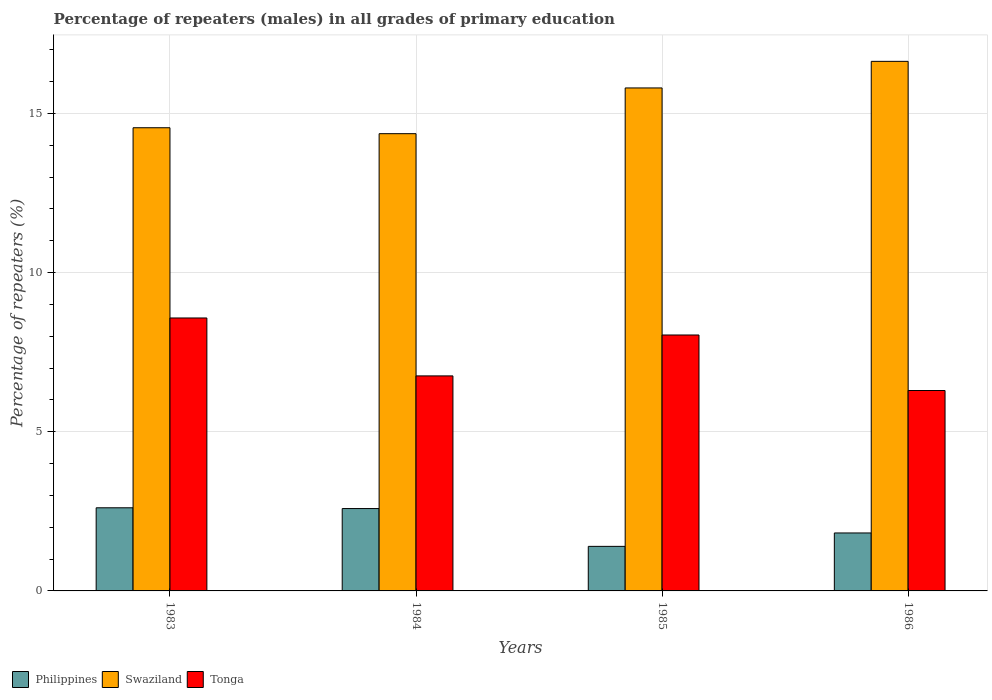Are the number of bars per tick equal to the number of legend labels?
Offer a very short reply. Yes. Are the number of bars on each tick of the X-axis equal?
Give a very brief answer. Yes. How many bars are there on the 2nd tick from the left?
Offer a very short reply. 3. In how many cases, is the number of bars for a given year not equal to the number of legend labels?
Your response must be concise. 0. What is the percentage of repeaters (males) in Swaziland in 1986?
Provide a short and direct response. 16.63. Across all years, what is the maximum percentage of repeaters (males) in Tonga?
Provide a short and direct response. 8.57. Across all years, what is the minimum percentage of repeaters (males) in Swaziland?
Provide a short and direct response. 14.36. In which year was the percentage of repeaters (males) in Swaziland maximum?
Your response must be concise. 1986. What is the total percentage of repeaters (males) in Swaziland in the graph?
Provide a short and direct response. 61.34. What is the difference between the percentage of repeaters (males) in Tonga in 1984 and that in 1986?
Make the answer very short. 0.46. What is the difference between the percentage of repeaters (males) in Swaziland in 1983 and the percentage of repeaters (males) in Tonga in 1984?
Provide a short and direct response. 7.79. What is the average percentage of repeaters (males) in Philippines per year?
Give a very brief answer. 2.1. In the year 1983, what is the difference between the percentage of repeaters (males) in Philippines and percentage of repeaters (males) in Tonga?
Keep it short and to the point. -5.96. What is the ratio of the percentage of repeaters (males) in Swaziland in 1984 to that in 1986?
Provide a succinct answer. 0.86. Is the percentage of repeaters (males) in Swaziland in 1983 less than that in 1984?
Offer a terse response. No. What is the difference between the highest and the second highest percentage of repeaters (males) in Swaziland?
Your answer should be compact. 0.84. What is the difference between the highest and the lowest percentage of repeaters (males) in Tonga?
Your response must be concise. 2.28. In how many years, is the percentage of repeaters (males) in Swaziland greater than the average percentage of repeaters (males) in Swaziland taken over all years?
Your response must be concise. 2. Is the sum of the percentage of repeaters (males) in Tonga in 1983 and 1986 greater than the maximum percentage of repeaters (males) in Swaziland across all years?
Your answer should be compact. No. What does the 2nd bar from the right in 1983 represents?
Your answer should be compact. Swaziland. How many bars are there?
Give a very brief answer. 12. How many years are there in the graph?
Your response must be concise. 4. Does the graph contain grids?
Provide a short and direct response. Yes. What is the title of the graph?
Your response must be concise. Percentage of repeaters (males) in all grades of primary education. Does "Middle East & North Africa (developing only)" appear as one of the legend labels in the graph?
Keep it short and to the point. No. What is the label or title of the Y-axis?
Your response must be concise. Percentage of repeaters (%). What is the Percentage of repeaters (%) of Philippines in 1983?
Your answer should be compact. 2.61. What is the Percentage of repeaters (%) in Swaziland in 1983?
Provide a short and direct response. 14.55. What is the Percentage of repeaters (%) in Tonga in 1983?
Your answer should be compact. 8.57. What is the Percentage of repeaters (%) in Philippines in 1984?
Give a very brief answer. 2.59. What is the Percentage of repeaters (%) in Swaziland in 1984?
Make the answer very short. 14.36. What is the Percentage of repeaters (%) of Tonga in 1984?
Give a very brief answer. 6.75. What is the Percentage of repeaters (%) of Philippines in 1985?
Your response must be concise. 1.4. What is the Percentage of repeaters (%) in Swaziland in 1985?
Keep it short and to the point. 15.8. What is the Percentage of repeaters (%) of Tonga in 1985?
Give a very brief answer. 8.04. What is the Percentage of repeaters (%) of Philippines in 1986?
Keep it short and to the point. 1.82. What is the Percentage of repeaters (%) in Swaziland in 1986?
Give a very brief answer. 16.63. What is the Percentage of repeaters (%) of Tonga in 1986?
Offer a very short reply. 6.3. Across all years, what is the maximum Percentage of repeaters (%) of Philippines?
Offer a very short reply. 2.61. Across all years, what is the maximum Percentage of repeaters (%) of Swaziland?
Your response must be concise. 16.63. Across all years, what is the maximum Percentage of repeaters (%) in Tonga?
Make the answer very short. 8.57. Across all years, what is the minimum Percentage of repeaters (%) of Philippines?
Offer a terse response. 1.4. Across all years, what is the minimum Percentage of repeaters (%) of Swaziland?
Provide a succinct answer. 14.36. Across all years, what is the minimum Percentage of repeaters (%) in Tonga?
Provide a succinct answer. 6.3. What is the total Percentage of repeaters (%) in Philippines in the graph?
Keep it short and to the point. 8.42. What is the total Percentage of repeaters (%) of Swaziland in the graph?
Make the answer very short. 61.34. What is the total Percentage of repeaters (%) in Tonga in the graph?
Keep it short and to the point. 29.66. What is the difference between the Percentage of repeaters (%) in Philippines in 1983 and that in 1984?
Ensure brevity in your answer.  0.02. What is the difference between the Percentage of repeaters (%) in Swaziland in 1983 and that in 1984?
Your response must be concise. 0.19. What is the difference between the Percentage of repeaters (%) of Tonga in 1983 and that in 1984?
Give a very brief answer. 1.82. What is the difference between the Percentage of repeaters (%) of Philippines in 1983 and that in 1985?
Your answer should be compact. 1.21. What is the difference between the Percentage of repeaters (%) of Swaziland in 1983 and that in 1985?
Provide a short and direct response. -1.25. What is the difference between the Percentage of repeaters (%) in Tonga in 1983 and that in 1985?
Make the answer very short. 0.53. What is the difference between the Percentage of repeaters (%) in Philippines in 1983 and that in 1986?
Offer a very short reply. 0.79. What is the difference between the Percentage of repeaters (%) of Swaziland in 1983 and that in 1986?
Your response must be concise. -2.09. What is the difference between the Percentage of repeaters (%) of Tonga in 1983 and that in 1986?
Make the answer very short. 2.28. What is the difference between the Percentage of repeaters (%) of Philippines in 1984 and that in 1985?
Your answer should be very brief. 1.19. What is the difference between the Percentage of repeaters (%) in Swaziland in 1984 and that in 1985?
Give a very brief answer. -1.44. What is the difference between the Percentage of repeaters (%) in Tonga in 1984 and that in 1985?
Give a very brief answer. -1.28. What is the difference between the Percentage of repeaters (%) in Philippines in 1984 and that in 1986?
Your answer should be very brief. 0.77. What is the difference between the Percentage of repeaters (%) of Swaziland in 1984 and that in 1986?
Ensure brevity in your answer.  -2.27. What is the difference between the Percentage of repeaters (%) of Tonga in 1984 and that in 1986?
Provide a short and direct response. 0.46. What is the difference between the Percentage of repeaters (%) in Philippines in 1985 and that in 1986?
Your response must be concise. -0.42. What is the difference between the Percentage of repeaters (%) in Swaziland in 1985 and that in 1986?
Your response must be concise. -0.83. What is the difference between the Percentage of repeaters (%) of Tonga in 1985 and that in 1986?
Offer a very short reply. 1.74. What is the difference between the Percentage of repeaters (%) in Philippines in 1983 and the Percentage of repeaters (%) in Swaziland in 1984?
Give a very brief answer. -11.75. What is the difference between the Percentage of repeaters (%) in Philippines in 1983 and the Percentage of repeaters (%) in Tonga in 1984?
Keep it short and to the point. -4.14. What is the difference between the Percentage of repeaters (%) of Swaziland in 1983 and the Percentage of repeaters (%) of Tonga in 1984?
Give a very brief answer. 7.79. What is the difference between the Percentage of repeaters (%) of Philippines in 1983 and the Percentage of repeaters (%) of Swaziland in 1985?
Offer a very short reply. -13.19. What is the difference between the Percentage of repeaters (%) of Philippines in 1983 and the Percentage of repeaters (%) of Tonga in 1985?
Ensure brevity in your answer.  -5.43. What is the difference between the Percentage of repeaters (%) in Swaziland in 1983 and the Percentage of repeaters (%) in Tonga in 1985?
Provide a short and direct response. 6.51. What is the difference between the Percentage of repeaters (%) of Philippines in 1983 and the Percentage of repeaters (%) of Swaziland in 1986?
Keep it short and to the point. -14.02. What is the difference between the Percentage of repeaters (%) of Philippines in 1983 and the Percentage of repeaters (%) of Tonga in 1986?
Offer a very short reply. -3.68. What is the difference between the Percentage of repeaters (%) of Swaziland in 1983 and the Percentage of repeaters (%) of Tonga in 1986?
Give a very brief answer. 8.25. What is the difference between the Percentage of repeaters (%) in Philippines in 1984 and the Percentage of repeaters (%) in Swaziland in 1985?
Keep it short and to the point. -13.21. What is the difference between the Percentage of repeaters (%) in Philippines in 1984 and the Percentage of repeaters (%) in Tonga in 1985?
Ensure brevity in your answer.  -5.45. What is the difference between the Percentage of repeaters (%) in Swaziland in 1984 and the Percentage of repeaters (%) in Tonga in 1985?
Offer a very short reply. 6.32. What is the difference between the Percentage of repeaters (%) in Philippines in 1984 and the Percentage of repeaters (%) in Swaziland in 1986?
Make the answer very short. -14.05. What is the difference between the Percentage of repeaters (%) of Philippines in 1984 and the Percentage of repeaters (%) of Tonga in 1986?
Provide a succinct answer. -3.71. What is the difference between the Percentage of repeaters (%) of Swaziland in 1984 and the Percentage of repeaters (%) of Tonga in 1986?
Make the answer very short. 8.07. What is the difference between the Percentage of repeaters (%) of Philippines in 1985 and the Percentage of repeaters (%) of Swaziland in 1986?
Your answer should be very brief. -15.23. What is the difference between the Percentage of repeaters (%) of Philippines in 1985 and the Percentage of repeaters (%) of Tonga in 1986?
Your answer should be compact. -4.9. What is the difference between the Percentage of repeaters (%) in Swaziland in 1985 and the Percentage of repeaters (%) in Tonga in 1986?
Offer a very short reply. 9.5. What is the average Percentage of repeaters (%) of Philippines per year?
Your answer should be compact. 2.1. What is the average Percentage of repeaters (%) in Swaziland per year?
Ensure brevity in your answer.  15.34. What is the average Percentage of repeaters (%) in Tonga per year?
Keep it short and to the point. 7.42. In the year 1983, what is the difference between the Percentage of repeaters (%) of Philippines and Percentage of repeaters (%) of Swaziland?
Give a very brief answer. -11.94. In the year 1983, what is the difference between the Percentage of repeaters (%) in Philippines and Percentage of repeaters (%) in Tonga?
Your answer should be very brief. -5.96. In the year 1983, what is the difference between the Percentage of repeaters (%) of Swaziland and Percentage of repeaters (%) of Tonga?
Your response must be concise. 5.97. In the year 1984, what is the difference between the Percentage of repeaters (%) in Philippines and Percentage of repeaters (%) in Swaziland?
Provide a short and direct response. -11.78. In the year 1984, what is the difference between the Percentage of repeaters (%) in Philippines and Percentage of repeaters (%) in Tonga?
Offer a terse response. -4.17. In the year 1984, what is the difference between the Percentage of repeaters (%) in Swaziland and Percentage of repeaters (%) in Tonga?
Give a very brief answer. 7.61. In the year 1985, what is the difference between the Percentage of repeaters (%) in Philippines and Percentage of repeaters (%) in Swaziland?
Keep it short and to the point. -14.4. In the year 1985, what is the difference between the Percentage of repeaters (%) of Philippines and Percentage of repeaters (%) of Tonga?
Provide a succinct answer. -6.64. In the year 1985, what is the difference between the Percentage of repeaters (%) of Swaziland and Percentage of repeaters (%) of Tonga?
Your response must be concise. 7.76. In the year 1986, what is the difference between the Percentage of repeaters (%) in Philippines and Percentage of repeaters (%) in Swaziland?
Keep it short and to the point. -14.81. In the year 1986, what is the difference between the Percentage of repeaters (%) of Philippines and Percentage of repeaters (%) of Tonga?
Provide a short and direct response. -4.47. In the year 1986, what is the difference between the Percentage of repeaters (%) in Swaziland and Percentage of repeaters (%) in Tonga?
Ensure brevity in your answer.  10.34. What is the ratio of the Percentage of repeaters (%) of Philippines in 1983 to that in 1984?
Provide a short and direct response. 1.01. What is the ratio of the Percentage of repeaters (%) of Swaziland in 1983 to that in 1984?
Provide a succinct answer. 1.01. What is the ratio of the Percentage of repeaters (%) in Tonga in 1983 to that in 1984?
Keep it short and to the point. 1.27. What is the ratio of the Percentage of repeaters (%) in Philippines in 1983 to that in 1985?
Keep it short and to the point. 1.87. What is the ratio of the Percentage of repeaters (%) in Swaziland in 1983 to that in 1985?
Make the answer very short. 0.92. What is the ratio of the Percentage of repeaters (%) in Tonga in 1983 to that in 1985?
Your answer should be compact. 1.07. What is the ratio of the Percentage of repeaters (%) in Philippines in 1983 to that in 1986?
Provide a short and direct response. 1.43. What is the ratio of the Percentage of repeaters (%) of Swaziland in 1983 to that in 1986?
Make the answer very short. 0.87. What is the ratio of the Percentage of repeaters (%) of Tonga in 1983 to that in 1986?
Your response must be concise. 1.36. What is the ratio of the Percentage of repeaters (%) in Philippines in 1984 to that in 1985?
Give a very brief answer. 1.85. What is the ratio of the Percentage of repeaters (%) of Tonga in 1984 to that in 1985?
Your answer should be very brief. 0.84. What is the ratio of the Percentage of repeaters (%) of Philippines in 1984 to that in 1986?
Ensure brevity in your answer.  1.42. What is the ratio of the Percentage of repeaters (%) in Swaziland in 1984 to that in 1986?
Offer a very short reply. 0.86. What is the ratio of the Percentage of repeaters (%) of Tonga in 1984 to that in 1986?
Offer a very short reply. 1.07. What is the ratio of the Percentage of repeaters (%) in Philippines in 1985 to that in 1986?
Offer a very short reply. 0.77. What is the ratio of the Percentage of repeaters (%) of Swaziland in 1985 to that in 1986?
Offer a very short reply. 0.95. What is the ratio of the Percentage of repeaters (%) in Tonga in 1985 to that in 1986?
Your answer should be compact. 1.28. What is the difference between the highest and the second highest Percentage of repeaters (%) of Philippines?
Ensure brevity in your answer.  0.02. What is the difference between the highest and the second highest Percentage of repeaters (%) of Swaziland?
Keep it short and to the point. 0.83. What is the difference between the highest and the second highest Percentage of repeaters (%) of Tonga?
Keep it short and to the point. 0.53. What is the difference between the highest and the lowest Percentage of repeaters (%) of Philippines?
Ensure brevity in your answer.  1.21. What is the difference between the highest and the lowest Percentage of repeaters (%) of Swaziland?
Offer a very short reply. 2.27. What is the difference between the highest and the lowest Percentage of repeaters (%) of Tonga?
Offer a very short reply. 2.28. 